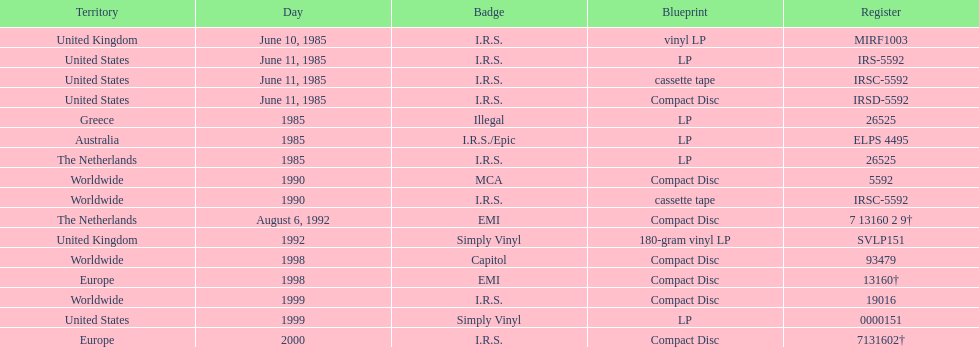Name another region for the 1985 release other than greece. Australia. 